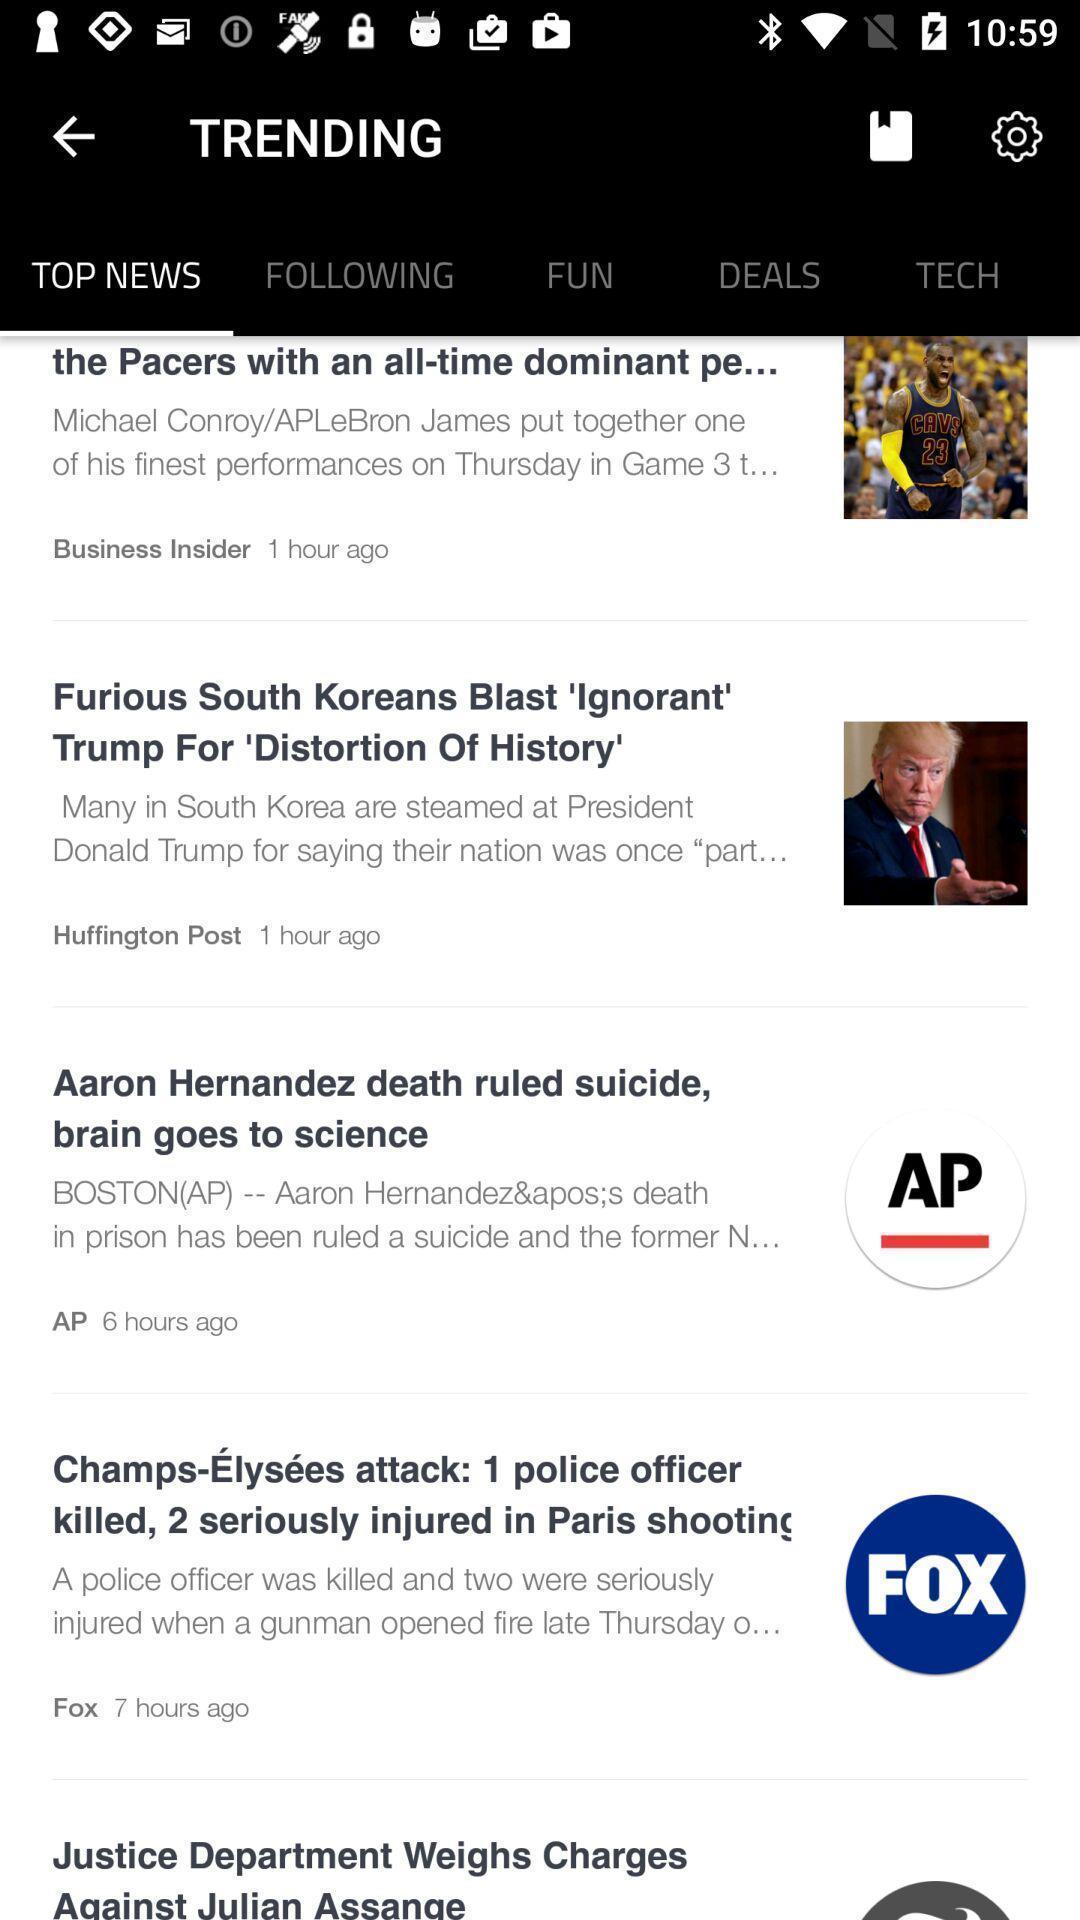Explain what's happening in this screen capture. Screen display top news page of a news app. 